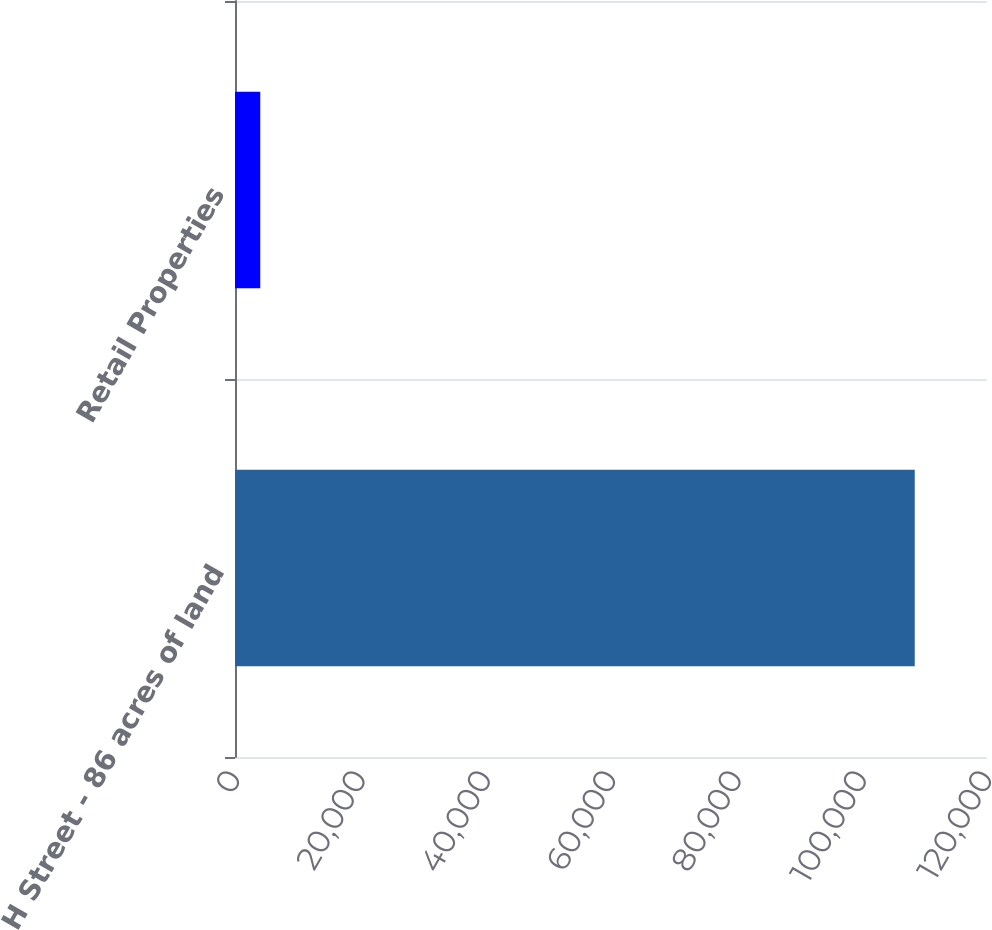Convert chart to OTSL. <chart><loc_0><loc_0><loc_500><loc_500><bar_chart><fcel>H Street - 86 acres of land<fcel>Retail Properties<nl><fcel>108470<fcel>4030<nl></chart> 